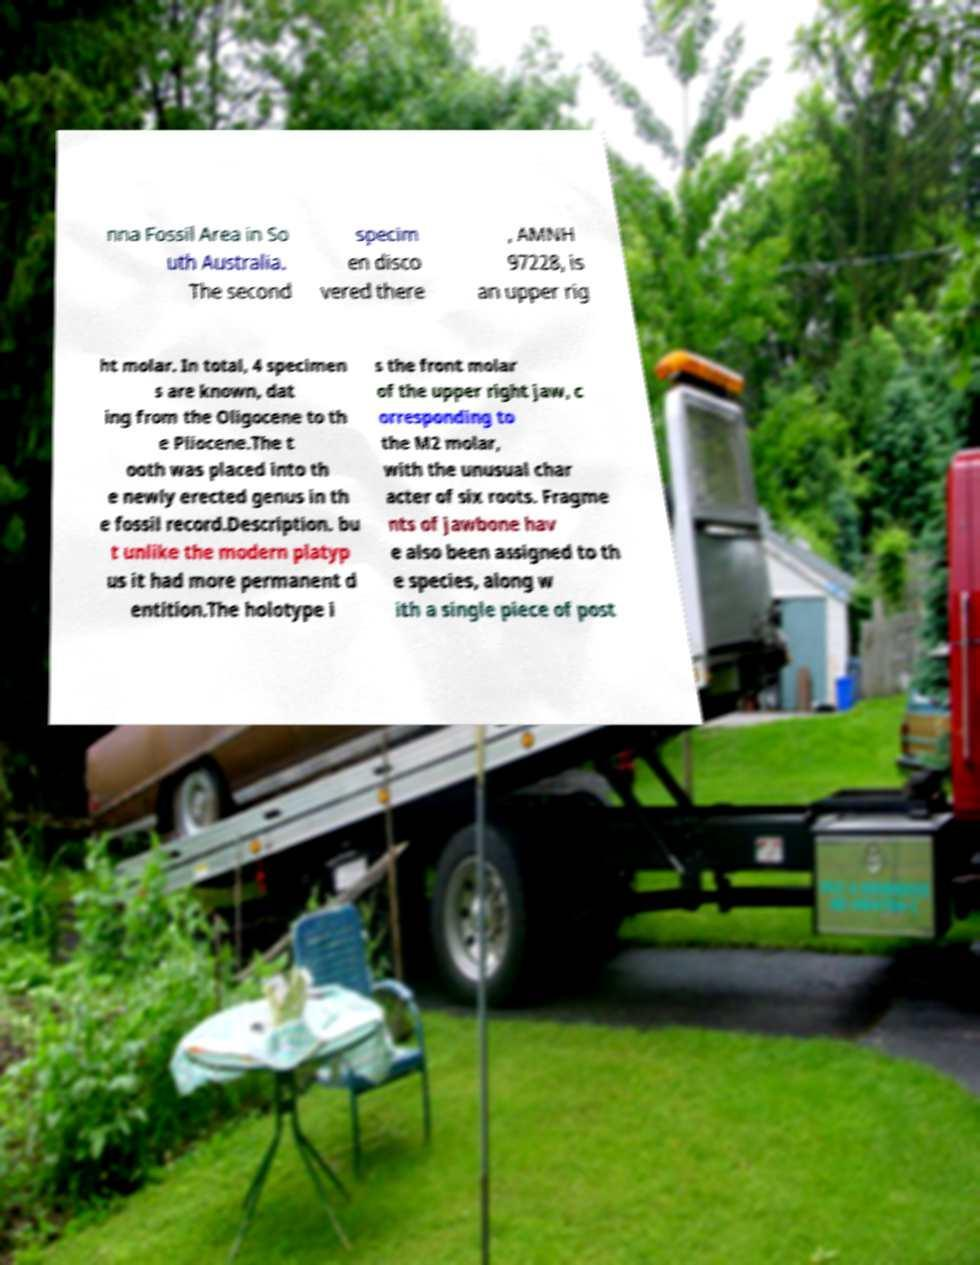For documentation purposes, I need the text within this image transcribed. Could you provide that? nna Fossil Area in So uth Australia. The second specim en disco vered there , AMNH 97228, is an upper rig ht molar. In total, 4 specimen s are known, dat ing from the Oligocene to th e Pliocene.The t ooth was placed into th e newly erected genus in th e fossil record.Description. bu t unlike the modern platyp us it had more permanent d entition.The holotype i s the front molar of the upper right jaw, c orresponding to the M2 molar, with the unusual char acter of six roots. Fragme nts of jawbone hav e also been assigned to th e species, along w ith a single piece of post 